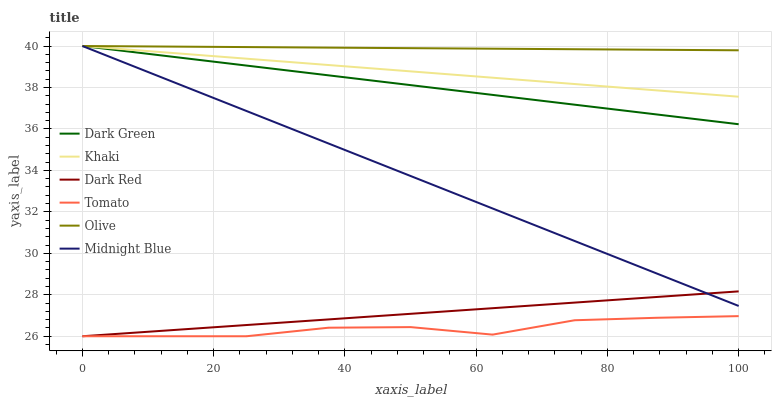Does Tomato have the minimum area under the curve?
Answer yes or no. Yes. Does Olive have the maximum area under the curve?
Answer yes or no. Yes. Does Khaki have the minimum area under the curve?
Answer yes or no. No. Does Khaki have the maximum area under the curve?
Answer yes or no. No. Is Dark Red the smoothest?
Answer yes or no. Yes. Is Tomato the roughest?
Answer yes or no. Yes. Is Khaki the smoothest?
Answer yes or no. No. Is Khaki the roughest?
Answer yes or no. No. Does Khaki have the lowest value?
Answer yes or no. No. Does Dark Green have the highest value?
Answer yes or no. Yes. Does Dark Red have the highest value?
Answer yes or no. No. Is Dark Red less than Olive?
Answer yes or no. Yes. Is Olive greater than Tomato?
Answer yes or no. Yes. Does Dark Red intersect Midnight Blue?
Answer yes or no. Yes. Is Dark Red less than Midnight Blue?
Answer yes or no. No. Is Dark Red greater than Midnight Blue?
Answer yes or no. No. Does Dark Red intersect Olive?
Answer yes or no. No. 